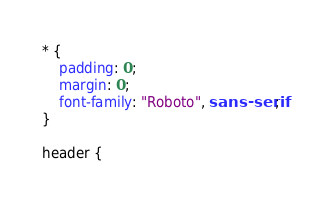Convert code to text. <code><loc_0><loc_0><loc_500><loc_500><_CSS_>* {
    padding: 0;
    margin: 0;
    font-family: "Roboto", sans-serif;
}

header {</code> 